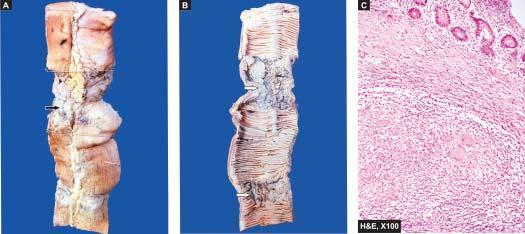how many strictures does the lumen show?
Answer the question using a single word or phrase. Two 